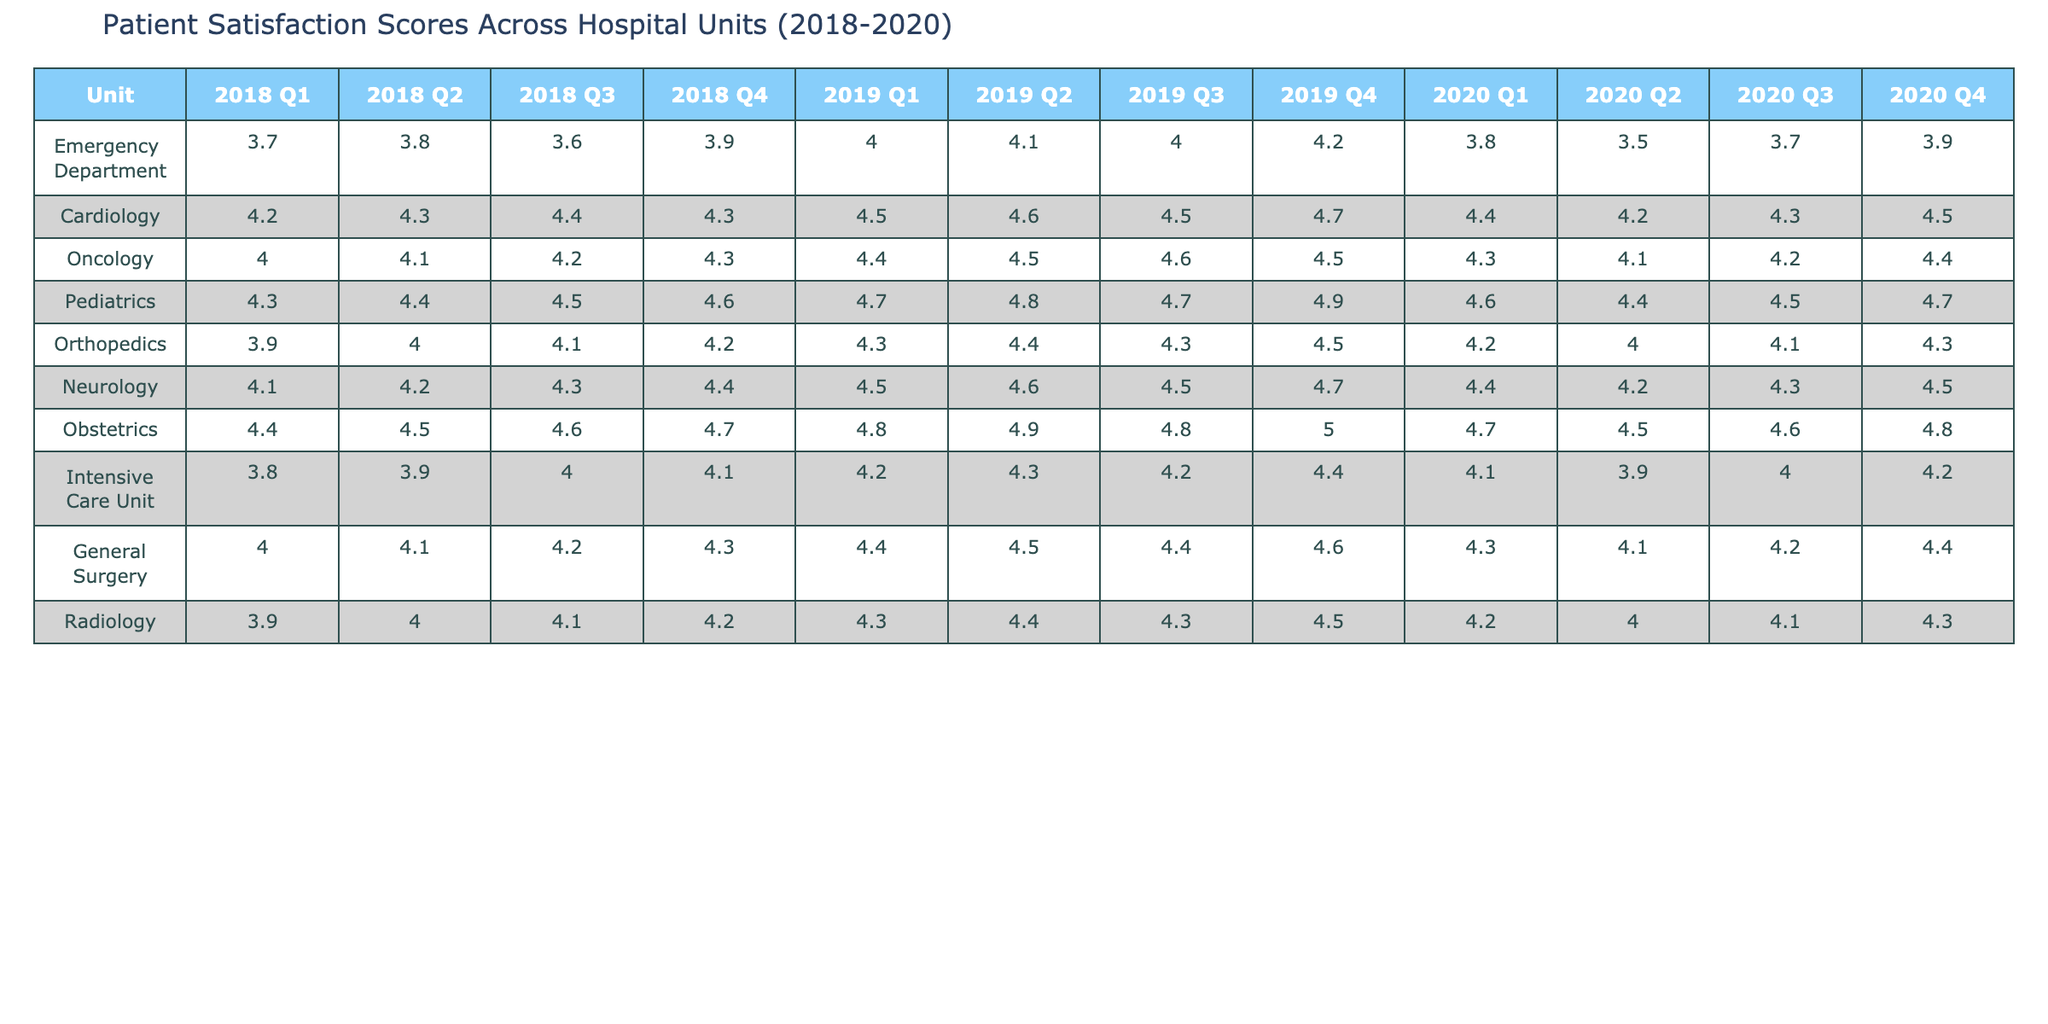What is the patient satisfaction score for the Emergency Department in 2019 Q1? The table shows that the score for the Emergency Department in 2019 Q1 is listed under the relevant column, which reads 4.0.
Answer: 4.0 Which unit had the highest patient satisfaction score in 2020 Q3? Looking at the table for the year 2020 and specifically for Q3, the scores for each unit are examined, and Obstetrics shows the highest score, which is 4.6.
Answer: 4.6 What was the average patient satisfaction score for Pediatrics from 2018 to 2020? The scores for Pediatrics are 4.3, 4.4, 4.5, 4.6, 4.7, 4.8, 4.7, 4.9, 4.6, 4.4, 4.5, and 4.7, which totals to 55.1. Dividing by the number of quarters (12) results in an average of 4.592, rounded to two decimal places is 4.59.
Answer: 4.59 Did the patient satisfaction scores for Cardiology ever drop below 4.2 during the study period? By examining all the scores for Cardiology throughout the quarters, the lowest score recorded is 4.2 in 2020 Q2, but it never dropped below this value. So, the answer is no.
Answer: No Which unit had the trend of increasing scores throughout the entire study period? Analyzing the patient satisfaction scores, it can be observed that Obstetrics consistently increased from 4.4 in 2018 Q1 to 5.0 in 2019 Q4. Therefore, this unit shows a clear upward trend in satisfaction scores.
Answer: Obstetrics What is the difference in the patient satisfaction score for the Intensive Care Unit between 2018 Q1 and 2020 Q4? The score for the Intensive Care Unit in 2018 Q1 is 3.8 and in 2020 Q4 is 4.2. Subtracting 3.8 from 4.2 gives a difference of 0.4.
Answer: 0.4 Which unit showed the most improvement in patient satisfaction from 2018 Q1 to 2020 Q4? Comparing the scores from 2018 Q1 to 2020 Q4 for each unit, Obstetrics improved from 4.4 to 4.8, which is an increase of 0.4. Other units can be checked, but no unit improved more significantly than this. Thus, Obstetrics shows the most improvement.
Answer: Obstetrics Was there any quarter where the score for Radiology was lower than 4.0? Upon reviewing the scores for Radiology, it is found that all reported scores are either equal to or greater than 4.0 during each quarter observed. Therefore, the answer is no.
Answer: No What is the score trend for Neurology across the three years? The scores for Neurology over the three years show consistent improvement, starting from 4.1 in 2018 Q1 to 4.5 in 2020 Q4. This indicates a positive trend in patient satisfaction for this unit.
Answer: Increasing trend 